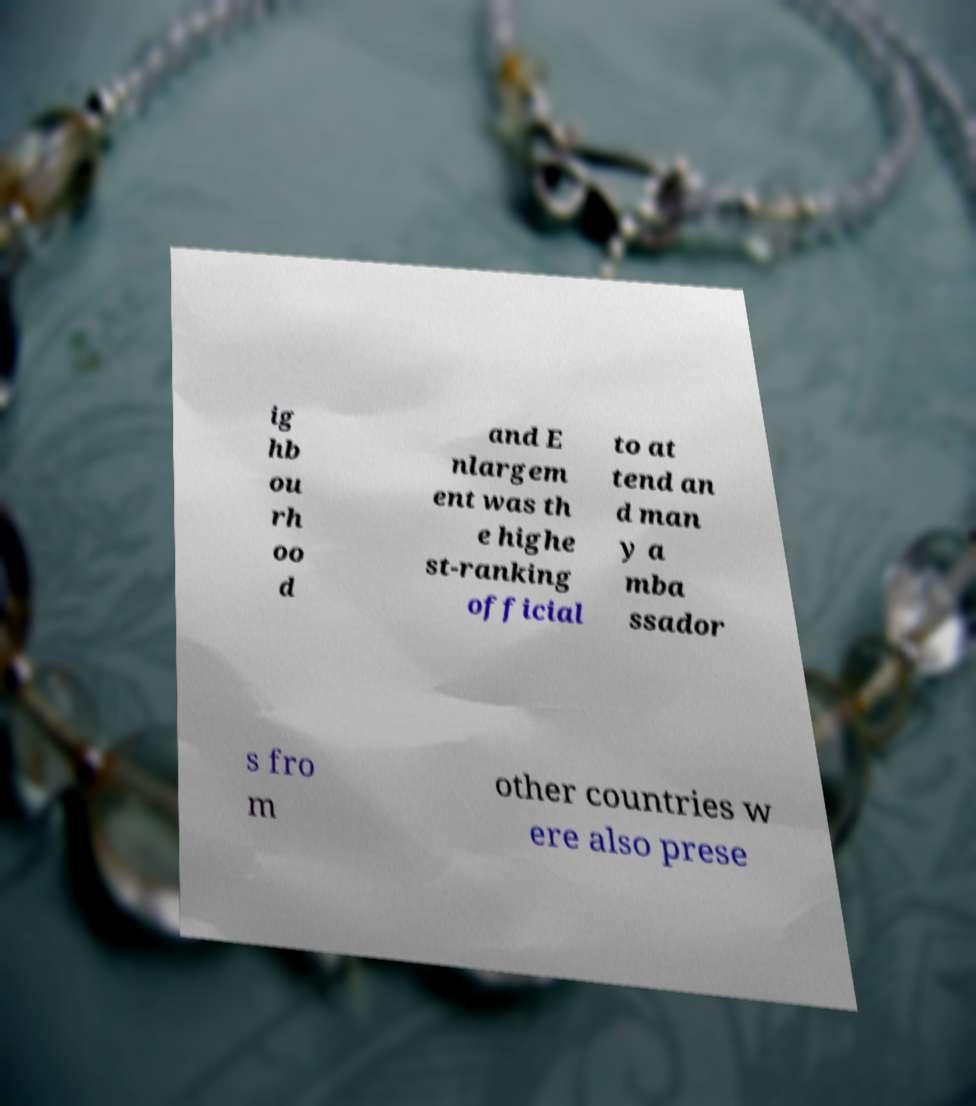Please read and relay the text visible in this image. What does it say? ig hb ou rh oo d and E nlargem ent was th e highe st-ranking official to at tend an d man y a mba ssador s fro m other countries w ere also prese 